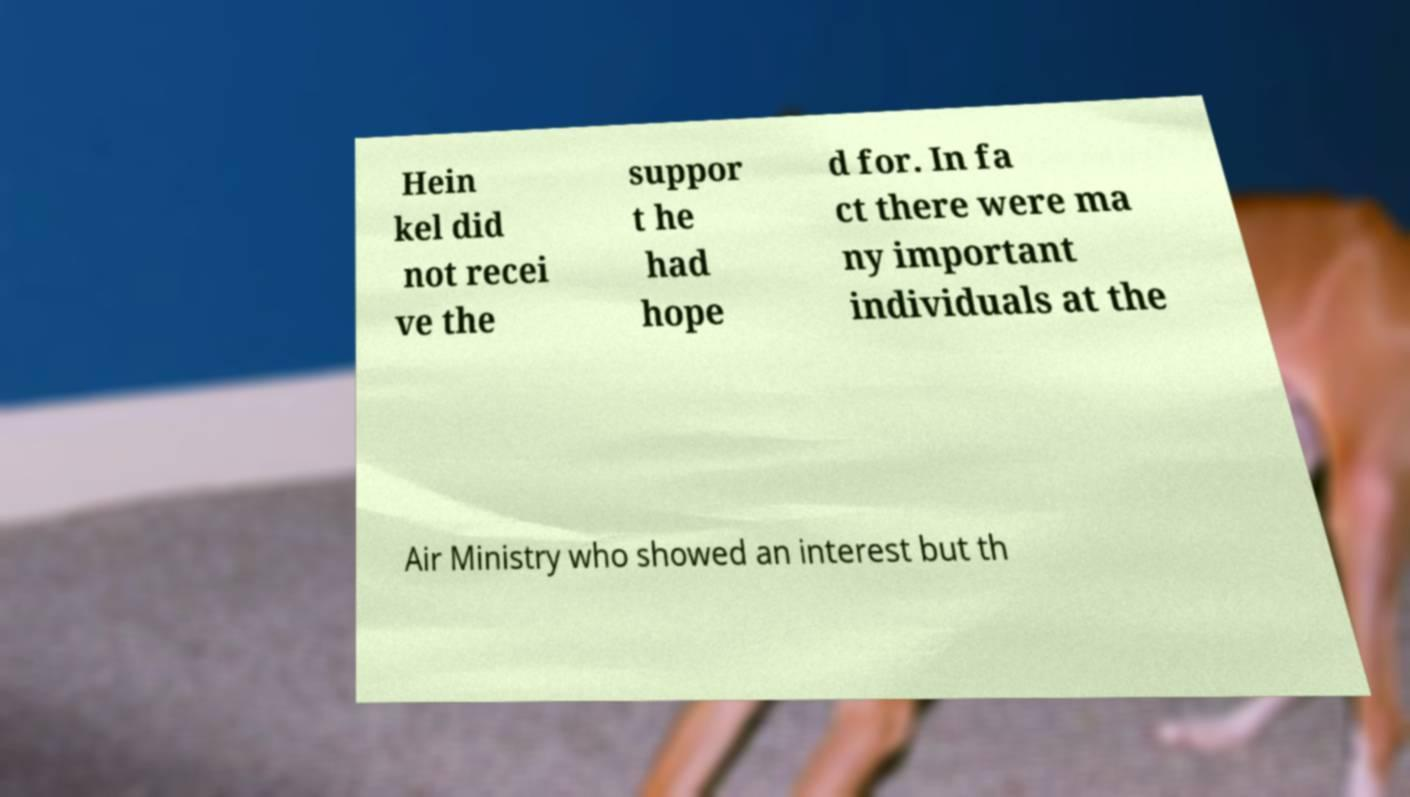Please read and relay the text visible in this image. What does it say? Hein kel did not recei ve the suppor t he had hope d for. In fa ct there were ma ny important individuals at the Air Ministry who showed an interest but th 